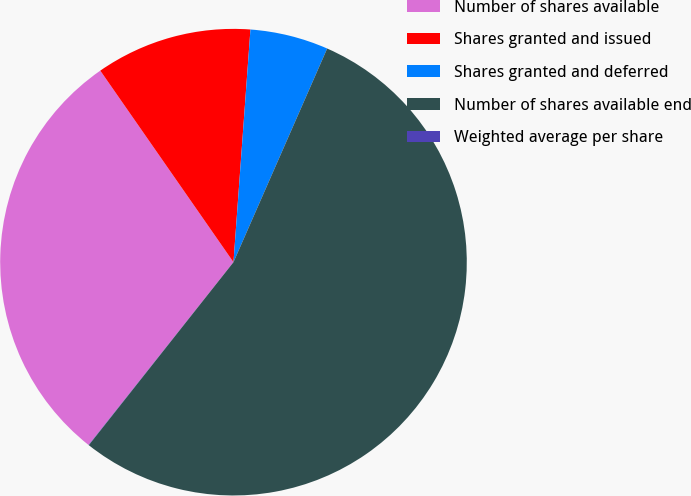Convert chart to OTSL. <chart><loc_0><loc_0><loc_500><loc_500><pie_chart><fcel>Number of shares available<fcel>Shares granted and issued<fcel>Shares granted and deferred<fcel>Number of shares available end<fcel>Weighted average per share<nl><fcel>29.66%<fcel>10.83%<fcel>5.42%<fcel>54.08%<fcel>0.02%<nl></chart> 